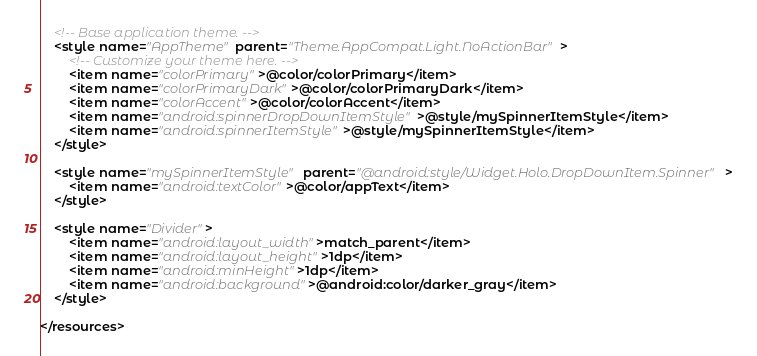<code> <loc_0><loc_0><loc_500><loc_500><_XML_>
    <!-- Base application theme. -->
    <style name="AppTheme" parent="Theme.AppCompat.Light.NoActionBar">
        <!-- Customize your theme here. -->
        <item name="colorPrimary">@color/colorPrimary</item>
        <item name="colorPrimaryDark">@color/colorPrimaryDark</item>
        <item name="colorAccent">@color/colorAccent</item>
        <item name="android:spinnerDropDownItemStyle">@style/mySpinnerItemStyle</item>
        <item name="android:spinnerItemStyle">@style/mySpinnerItemStyle</item>
    </style>

    <style name="mySpinnerItemStyle" parent="@android:style/Widget.Holo.DropDownItem.Spinner">
        <item name="android:textColor">@color/appText</item>
    </style>

    <style name="Divider">
        <item name="android:layout_width">match_parent</item>
        <item name="android:layout_height">1dp</item>
        <item name="android:minHeight">1dp</item>
        <item name="android:background">@android:color/darker_gray</item>
    </style>

</resources>
</code> 